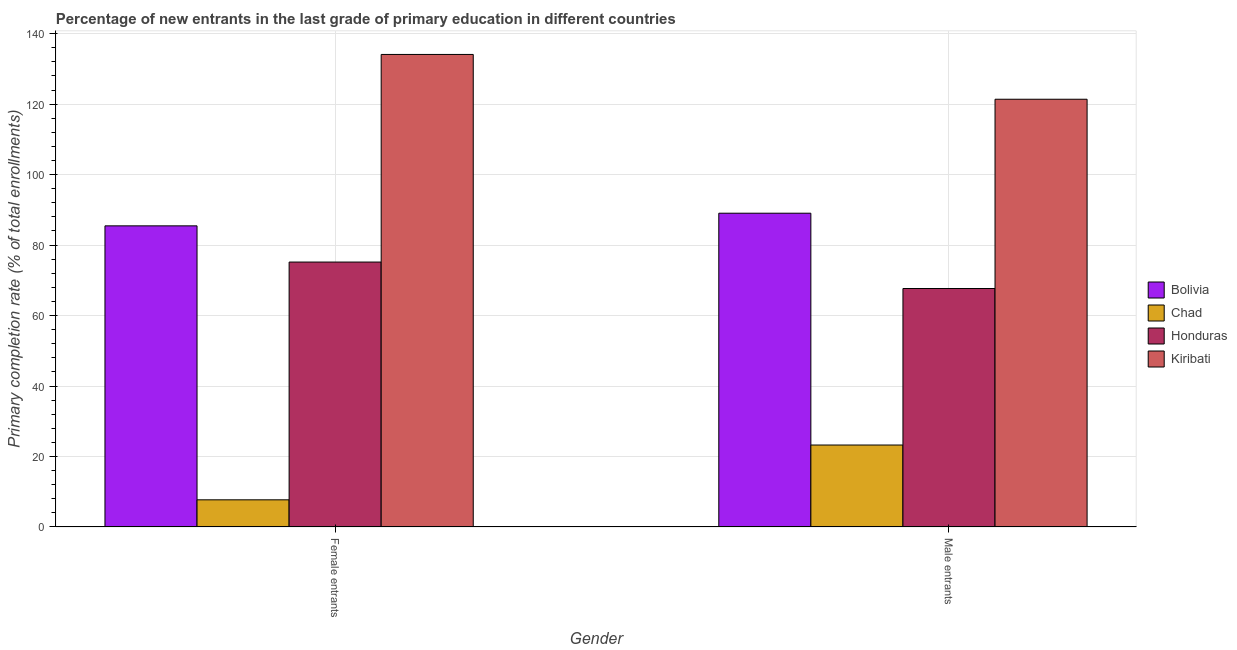How many different coloured bars are there?
Keep it short and to the point. 4. How many groups of bars are there?
Your answer should be very brief. 2. How many bars are there on the 2nd tick from the right?
Offer a very short reply. 4. What is the label of the 2nd group of bars from the left?
Your answer should be very brief. Male entrants. What is the primary completion rate of female entrants in Chad?
Your response must be concise. 7.71. Across all countries, what is the maximum primary completion rate of male entrants?
Provide a succinct answer. 121.38. Across all countries, what is the minimum primary completion rate of female entrants?
Provide a succinct answer. 7.71. In which country was the primary completion rate of female entrants maximum?
Your answer should be compact. Kiribati. In which country was the primary completion rate of male entrants minimum?
Your answer should be very brief. Chad. What is the total primary completion rate of male entrants in the graph?
Your response must be concise. 301.36. What is the difference between the primary completion rate of female entrants in Kiribati and that in Honduras?
Keep it short and to the point. 58.91. What is the difference between the primary completion rate of female entrants in Honduras and the primary completion rate of male entrants in Chad?
Offer a very short reply. 51.92. What is the average primary completion rate of female entrants per country?
Provide a succinct answer. 75.61. What is the difference between the primary completion rate of male entrants and primary completion rate of female entrants in Kiribati?
Provide a short and direct response. -12.71. In how many countries, is the primary completion rate of female entrants greater than 56 %?
Make the answer very short. 3. What is the ratio of the primary completion rate of male entrants in Kiribati to that in Bolivia?
Your answer should be compact. 1.36. In how many countries, is the primary completion rate of female entrants greater than the average primary completion rate of female entrants taken over all countries?
Your response must be concise. 2. What does the 1st bar from the left in Female entrants represents?
Offer a very short reply. Bolivia. What does the 3rd bar from the right in Female entrants represents?
Keep it short and to the point. Chad. Are all the bars in the graph horizontal?
Offer a terse response. No. How many countries are there in the graph?
Give a very brief answer. 4. What is the difference between two consecutive major ticks on the Y-axis?
Your response must be concise. 20. Are the values on the major ticks of Y-axis written in scientific E-notation?
Offer a terse response. No. Does the graph contain any zero values?
Ensure brevity in your answer.  No. What is the title of the graph?
Offer a very short reply. Percentage of new entrants in the last grade of primary education in different countries. Does "Chad" appear as one of the legend labels in the graph?
Provide a short and direct response. Yes. What is the label or title of the X-axis?
Your answer should be very brief. Gender. What is the label or title of the Y-axis?
Ensure brevity in your answer.  Primary completion rate (% of total enrollments). What is the Primary completion rate (% of total enrollments) of Bolivia in Female entrants?
Keep it short and to the point. 85.45. What is the Primary completion rate (% of total enrollments) of Chad in Female entrants?
Provide a succinct answer. 7.71. What is the Primary completion rate (% of total enrollments) in Honduras in Female entrants?
Ensure brevity in your answer.  75.18. What is the Primary completion rate (% of total enrollments) in Kiribati in Female entrants?
Offer a very short reply. 134.09. What is the Primary completion rate (% of total enrollments) of Bolivia in Male entrants?
Provide a short and direct response. 89.04. What is the Primary completion rate (% of total enrollments) of Chad in Male entrants?
Your response must be concise. 23.26. What is the Primary completion rate (% of total enrollments) of Honduras in Male entrants?
Your answer should be very brief. 67.68. What is the Primary completion rate (% of total enrollments) in Kiribati in Male entrants?
Give a very brief answer. 121.38. Across all Gender, what is the maximum Primary completion rate (% of total enrollments) in Bolivia?
Your response must be concise. 89.04. Across all Gender, what is the maximum Primary completion rate (% of total enrollments) of Chad?
Give a very brief answer. 23.26. Across all Gender, what is the maximum Primary completion rate (% of total enrollments) of Honduras?
Provide a short and direct response. 75.18. Across all Gender, what is the maximum Primary completion rate (% of total enrollments) of Kiribati?
Ensure brevity in your answer.  134.09. Across all Gender, what is the minimum Primary completion rate (% of total enrollments) of Bolivia?
Make the answer very short. 85.45. Across all Gender, what is the minimum Primary completion rate (% of total enrollments) of Chad?
Give a very brief answer. 7.71. Across all Gender, what is the minimum Primary completion rate (% of total enrollments) in Honduras?
Give a very brief answer. 67.68. Across all Gender, what is the minimum Primary completion rate (% of total enrollments) in Kiribati?
Make the answer very short. 121.38. What is the total Primary completion rate (% of total enrollments) of Bolivia in the graph?
Provide a succinct answer. 174.5. What is the total Primary completion rate (% of total enrollments) in Chad in the graph?
Give a very brief answer. 30.97. What is the total Primary completion rate (% of total enrollments) of Honduras in the graph?
Offer a terse response. 142.86. What is the total Primary completion rate (% of total enrollments) in Kiribati in the graph?
Provide a succinct answer. 255.48. What is the difference between the Primary completion rate (% of total enrollments) of Bolivia in Female entrants and that in Male entrants?
Your answer should be compact. -3.59. What is the difference between the Primary completion rate (% of total enrollments) in Chad in Female entrants and that in Male entrants?
Keep it short and to the point. -15.55. What is the difference between the Primary completion rate (% of total enrollments) of Honduras in Female entrants and that in Male entrants?
Ensure brevity in your answer.  7.51. What is the difference between the Primary completion rate (% of total enrollments) of Kiribati in Female entrants and that in Male entrants?
Ensure brevity in your answer.  12.71. What is the difference between the Primary completion rate (% of total enrollments) of Bolivia in Female entrants and the Primary completion rate (% of total enrollments) of Chad in Male entrants?
Ensure brevity in your answer.  62.2. What is the difference between the Primary completion rate (% of total enrollments) of Bolivia in Female entrants and the Primary completion rate (% of total enrollments) of Honduras in Male entrants?
Your answer should be compact. 17.78. What is the difference between the Primary completion rate (% of total enrollments) in Bolivia in Female entrants and the Primary completion rate (% of total enrollments) in Kiribati in Male entrants?
Your answer should be compact. -35.93. What is the difference between the Primary completion rate (% of total enrollments) of Chad in Female entrants and the Primary completion rate (% of total enrollments) of Honduras in Male entrants?
Offer a terse response. -59.97. What is the difference between the Primary completion rate (% of total enrollments) in Chad in Female entrants and the Primary completion rate (% of total enrollments) in Kiribati in Male entrants?
Keep it short and to the point. -113.67. What is the difference between the Primary completion rate (% of total enrollments) of Honduras in Female entrants and the Primary completion rate (% of total enrollments) of Kiribati in Male entrants?
Give a very brief answer. -46.2. What is the average Primary completion rate (% of total enrollments) in Bolivia per Gender?
Ensure brevity in your answer.  87.25. What is the average Primary completion rate (% of total enrollments) in Chad per Gender?
Offer a very short reply. 15.49. What is the average Primary completion rate (% of total enrollments) of Honduras per Gender?
Make the answer very short. 71.43. What is the average Primary completion rate (% of total enrollments) in Kiribati per Gender?
Offer a terse response. 127.74. What is the difference between the Primary completion rate (% of total enrollments) of Bolivia and Primary completion rate (% of total enrollments) of Chad in Female entrants?
Your response must be concise. 77.74. What is the difference between the Primary completion rate (% of total enrollments) in Bolivia and Primary completion rate (% of total enrollments) in Honduras in Female entrants?
Offer a very short reply. 10.27. What is the difference between the Primary completion rate (% of total enrollments) of Bolivia and Primary completion rate (% of total enrollments) of Kiribati in Female entrants?
Provide a short and direct response. -48.64. What is the difference between the Primary completion rate (% of total enrollments) in Chad and Primary completion rate (% of total enrollments) in Honduras in Female entrants?
Your answer should be very brief. -67.47. What is the difference between the Primary completion rate (% of total enrollments) of Chad and Primary completion rate (% of total enrollments) of Kiribati in Female entrants?
Keep it short and to the point. -126.38. What is the difference between the Primary completion rate (% of total enrollments) of Honduras and Primary completion rate (% of total enrollments) of Kiribati in Female entrants?
Ensure brevity in your answer.  -58.91. What is the difference between the Primary completion rate (% of total enrollments) in Bolivia and Primary completion rate (% of total enrollments) in Chad in Male entrants?
Make the answer very short. 65.78. What is the difference between the Primary completion rate (% of total enrollments) of Bolivia and Primary completion rate (% of total enrollments) of Honduras in Male entrants?
Make the answer very short. 21.37. What is the difference between the Primary completion rate (% of total enrollments) in Bolivia and Primary completion rate (% of total enrollments) in Kiribati in Male entrants?
Provide a short and direct response. -32.34. What is the difference between the Primary completion rate (% of total enrollments) in Chad and Primary completion rate (% of total enrollments) in Honduras in Male entrants?
Offer a very short reply. -44.42. What is the difference between the Primary completion rate (% of total enrollments) of Chad and Primary completion rate (% of total enrollments) of Kiribati in Male entrants?
Your response must be concise. -98.12. What is the difference between the Primary completion rate (% of total enrollments) of Honduras and Primary completion rate (% of total enrollments) of Kiribati in Male entrants?
Offer a very short reply. -53.71. What is the ratio of the Primary completion rate (% of total enrollments) in Bolivia in Female entrants to that in Male entrants?
Ensure brevity in your answer.  0.96. What is the ratio of the Primary completion rate (% of total enrollments) of Chad in Female entrants to that in Male entrants?
Your answer should be very brief. 0.33. What is the ratio of the Primary completion rate (% of total enrollments) in Honduras in Female entrants to that in Male entrants?
Your answer should be very brief. 1.11. What is the ratio of the Primary completion rate (% of total enrollments) in Kiribati in Female entrants to that in Male entrants?
Your response must be concise. 1.1. What is the difference between the highest and the second highest Primary completion rate (% of total enrollments) in Bolivia?
Provide a short and direct response. 3.59. What is the difference between the highest and the second highest Primary completion rate (% of total enrollments) of Chad?
Give a very brief answer. 15.55. What is the difference between the highest and the second highest Primary completion rate (% of total enrollments) in Honduras?
Offer a very short reply. 7.51. What is the difference between the highest and the second highest Primary completion rate (% of total enrollments) of Kiribati?
Your response must be concise. 12.71. What is the difference between the highest and the lowest Primary completion rate (% of total enrollments) in Bolivia?
Keep it short and to the point. 3.59. What is the difference between the highest and the lowest Primary completion rate (% of total enrollments) of Chad?
Your answer should be compact. 15.55. What is the difference between the highest and the lowest Primary completion rate (% of total enrollments) in Honduras?
Offer a terse response. 7.51. What is the difference between the highest and the lowest Primary completion rate (% of total enrollments) of Kiribati?
Ensure brevity in your answer.  12.71. 